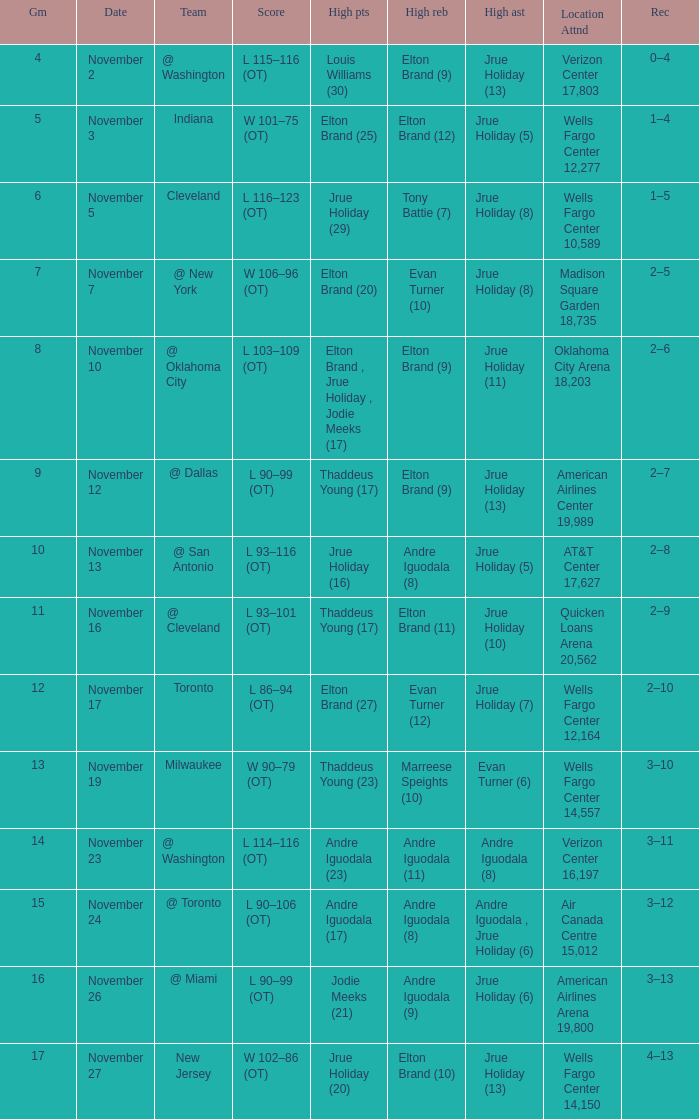What is the score for the game with the record of 3–12? L 90–106 (OT). 